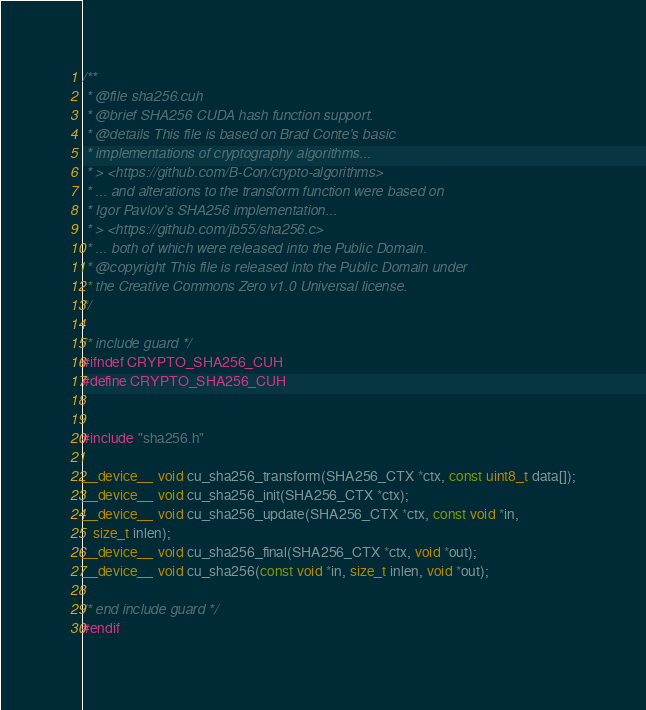Convert code to text. <code><loc_0><loc_0><loc_500><loc_500><_Cuda_>/**
 * @file sha256.cuh
 * @brief SHA256 CUDA hash function support.
 * @details This file is based on Brad Conte's basic
 * implementations of cryptography algorithms...
 * > <https://github.com/B-Con/crypto-algorithms>
 * ... and alterations to the transform function were based on
 * Igor Pavlov's SHA256 implementation...
 * > <https://github.com/jb55/sha256.c>
 * ... both of which were released into the Public Domain.
 * @copyright This file is released into the Public Domain under
 * the Creative Commons Zero v1.0 Universal license.
*/

/* include guard */
#ifndef CRYPTO_SHA256_CUH
#define CRYPTO_SHA256_CUH


#include "sha256.h"

__device__ void cu_sha256_transform(SHA256_CTX *ctx, const uint8_t data[]);
__device__ void cu_sha256_init(SHA256_CTX *ctx);
__device__ void cu_sha256_update(SHA256_CTX *ctx, const void *in,
   size_t inlen);
__device__ void cu_sha256_final(SHA256_CTX *ctx, void *out);
__device__ void cu_sha256(const void *in, size_t inlen, void *out);

/* end include guard */
#endif
</code> 